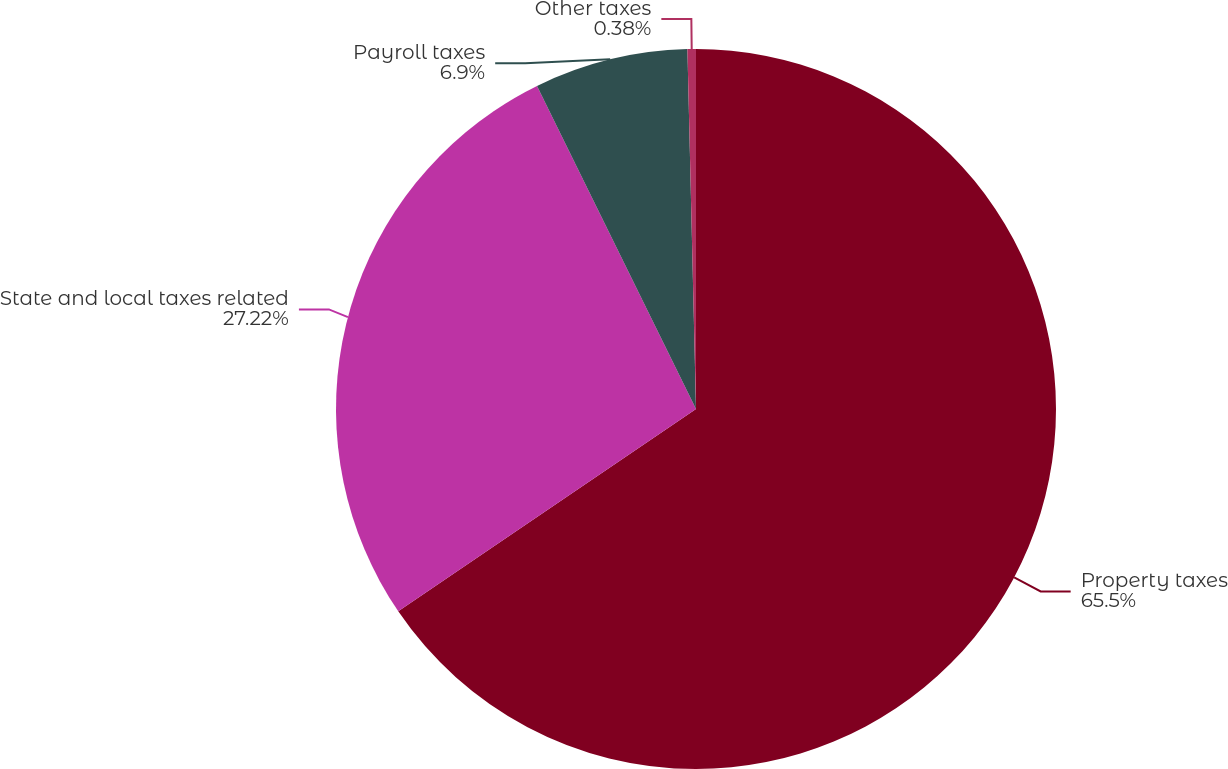Convert chart to OTSL. <chart><loc_0><loc_0><loc_500><loc_500><pie_chart><fcel>Property taxes<fcel>State and local taxes related<fcel>Payroll taxes<fcel>Other taxes<nl><fcel>65.5%<fcel>27.22%<fcel>6.9%<fcel>0.38%<nl></chart> 